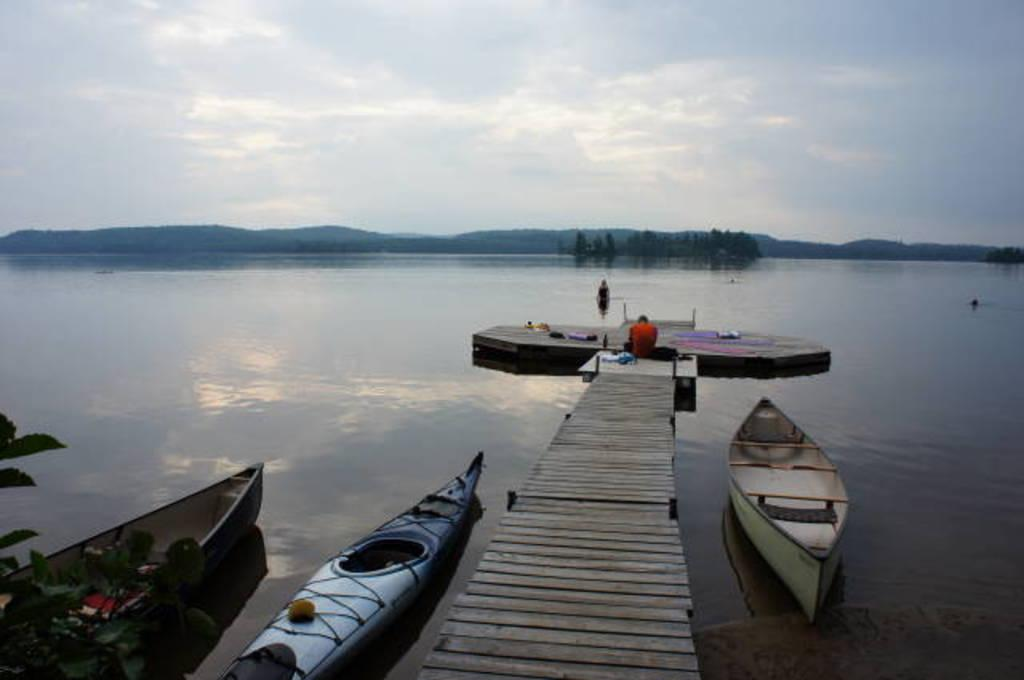What type of vehicles are in the water in the image? There are boats in the water in the image. Where is the man located in the image? The man is sitting on a wooden bridge in the middle of the image. What is the primary element visible in the image? Water is visible in the image. What is visible at the top of the image? The sky is visible at the top of the image. What type of sugar is being used to fuel the boats in the image? There is no sugar present in the image, and boats do not use sugar as fuel. How does the man on the bridge express his feelings of hate in the image? There is no indication of hate or any negative emotions in the image; the man is simply sitting on a wooden bridge. 